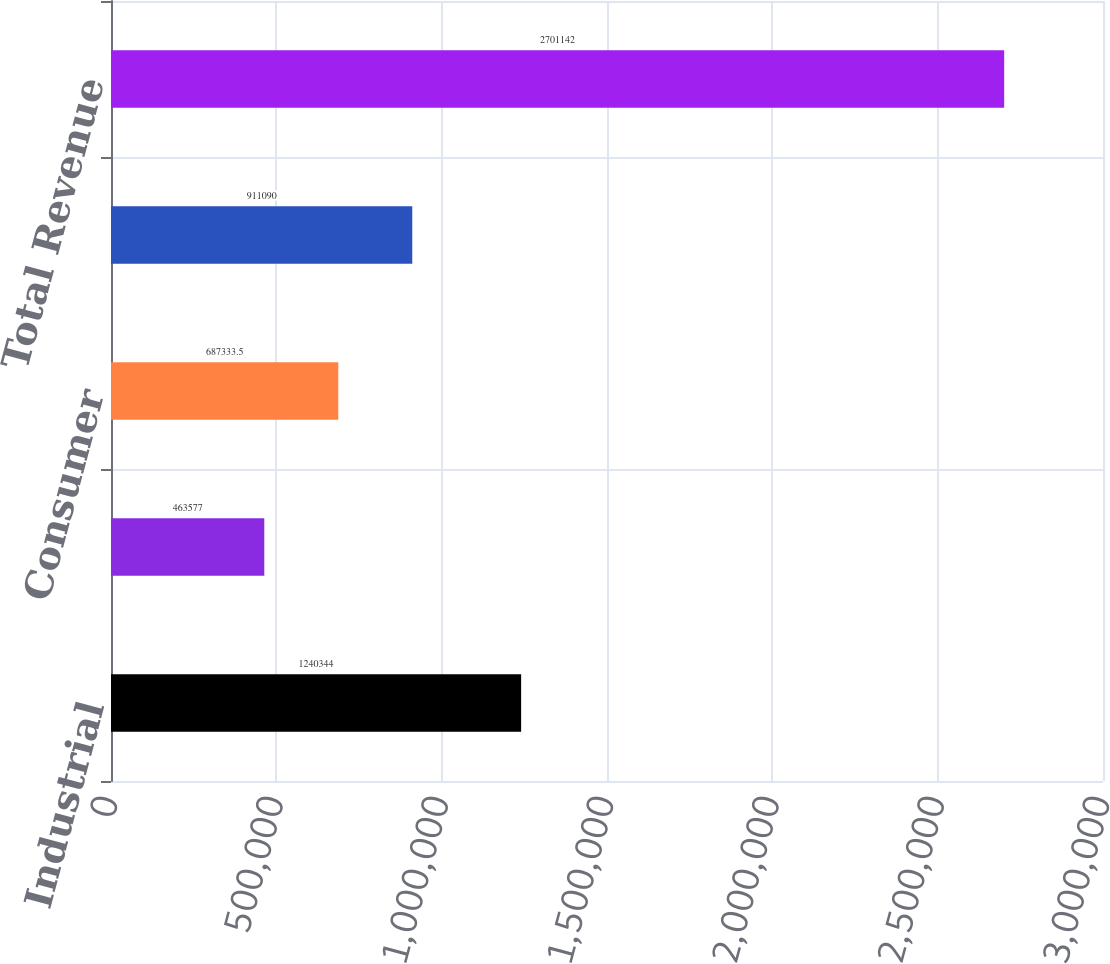<chart> <loc_0><loc_0><loc_500><loc_500><bar_chart><fcel>Industrial<fcel>Automotive<fcel>Consumer<fcel>Communications<fcel>Total Revenue<nl><fcel>1.24034e+06<fcel>463577<fcel>687334<fcel>911090<fcel>2.70114e+06<nl></chart> 